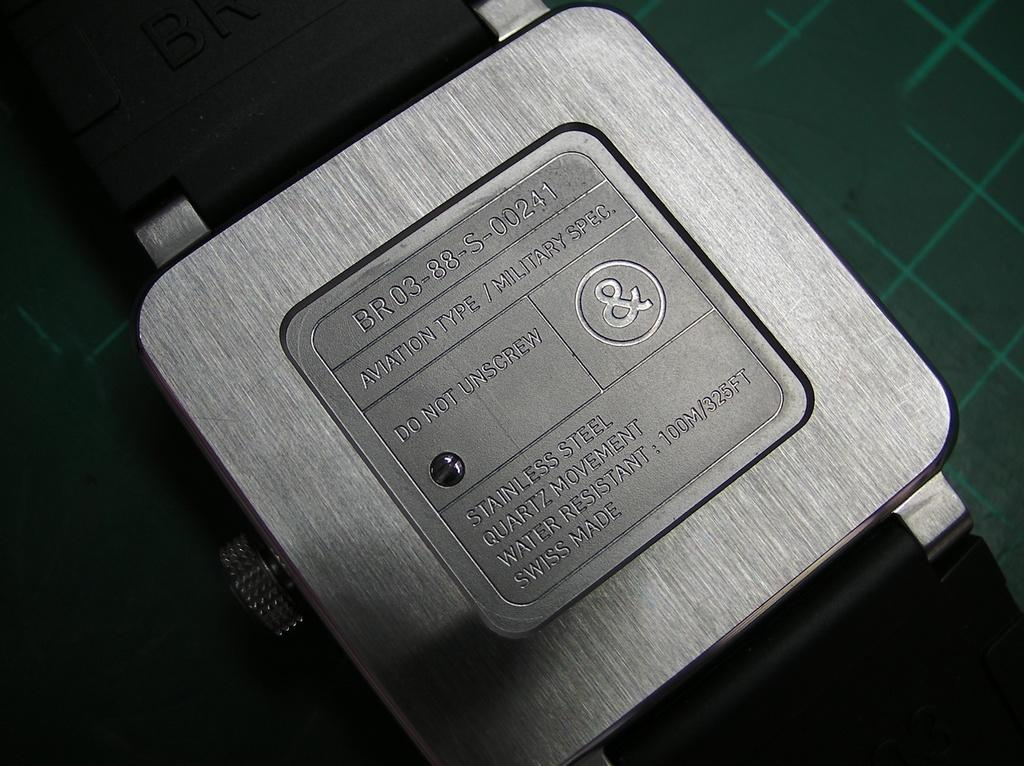<image>
Write a terse but informative summary of the picture. A silver box is etched with the words "Aviation Type". 